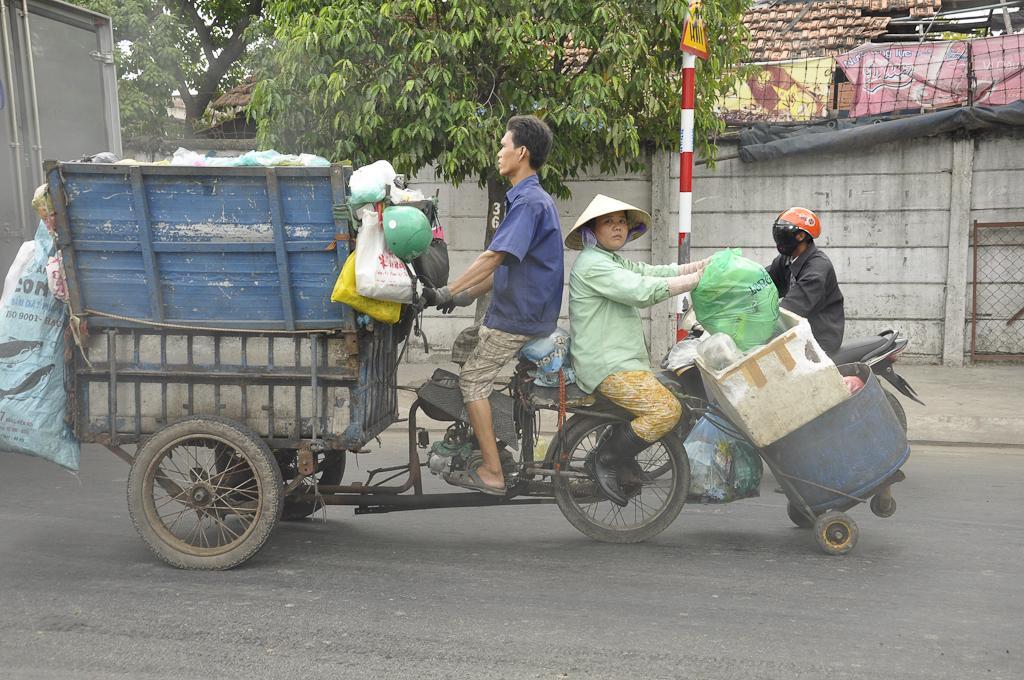In one or two sentences, can you explain what this image depicts? In this picture, On the road we can see 2 people sitting in a garbage van. In the background, we can see a house, trees, a pole and a person on the bike. 